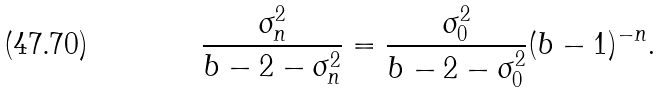Convert formula to latex. <formula><loc_0><loc_0><loc_500><loc_500>\frac { \sigma _ { n } ^ { 2 } } { b - 2 - \sigma _ { n } ^ { 2 } } = \frac { \sigma _ { 0 } ^ { 2 } } { b - 2 - \sigma _ { 0 } ^ { 2 } } ( b - 1 ) ^ { - n } .</formula> 